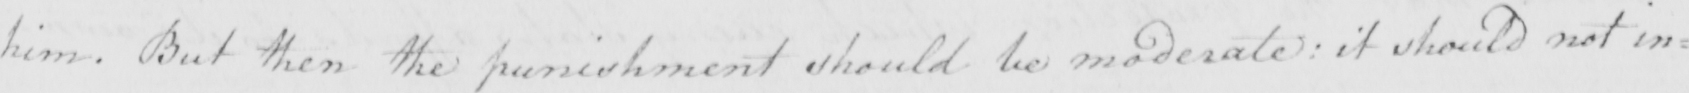Can you read and transcribe this handwriting? him . But then the punishment should be moderate :  it should not in= 